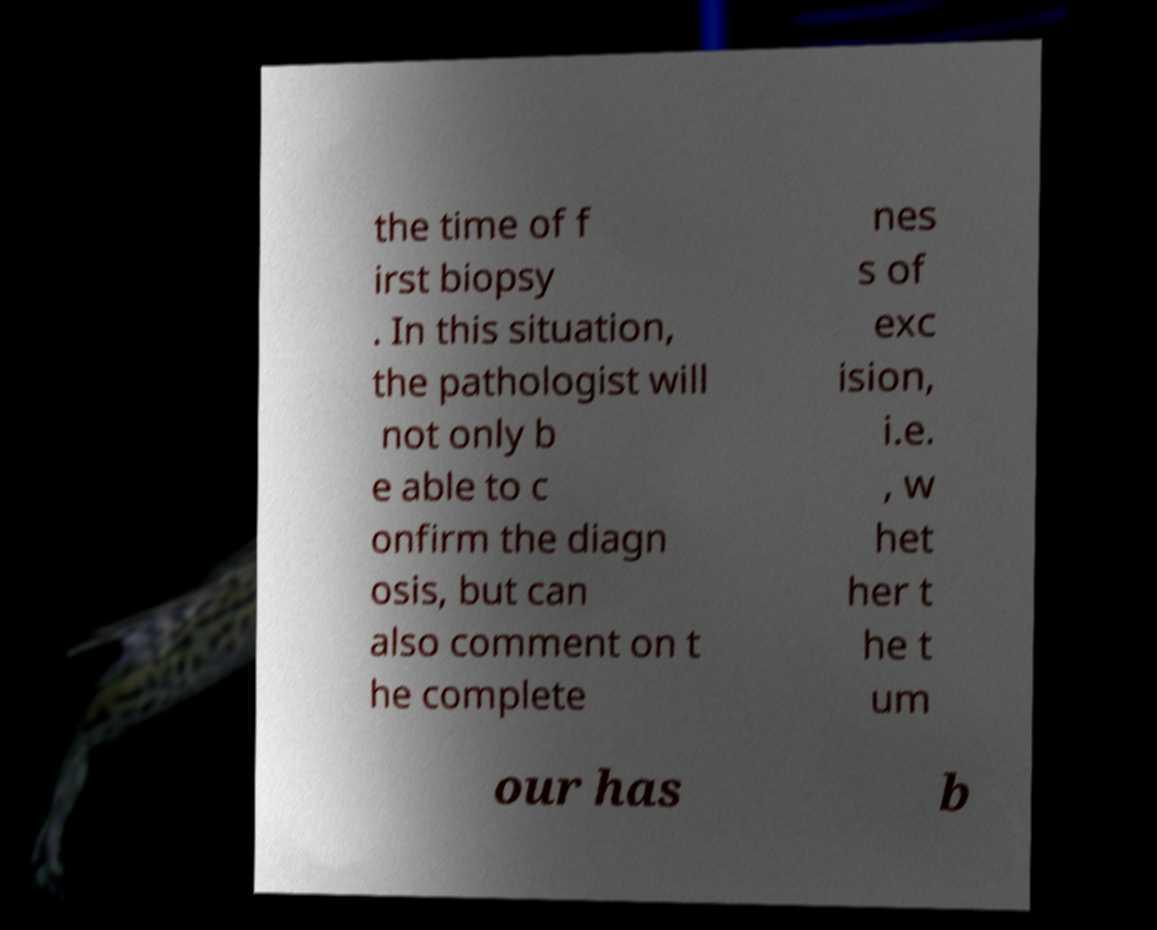Could you assist in decoding the text presented in this image and type it out clearly? the time of f irst biopsy . In this situation, the pathologist will not only b e able to c onfirm the diagn osis, but can also comment on t he complete nes s of exc ision, i.e. , w het her t he t um our has b 